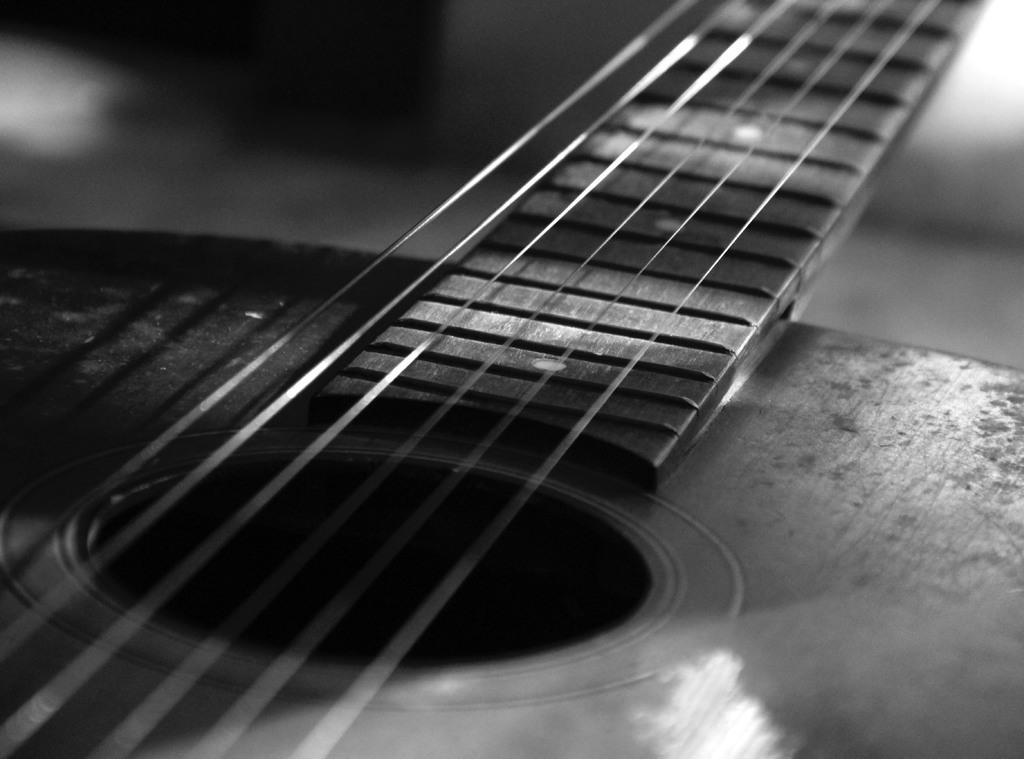What musical instrument is present in the image? There is a guitar in the image. What feature of the guitar is mentioned in the facts? The guitar has strings. How many trucks are parked in the office in the image? There are no trucks or offices present in the image; it features a guitar with strings. What type of powder is sprinkled on the guitar in the image? There is no powder present on the guitar in the image; it only has strings. 